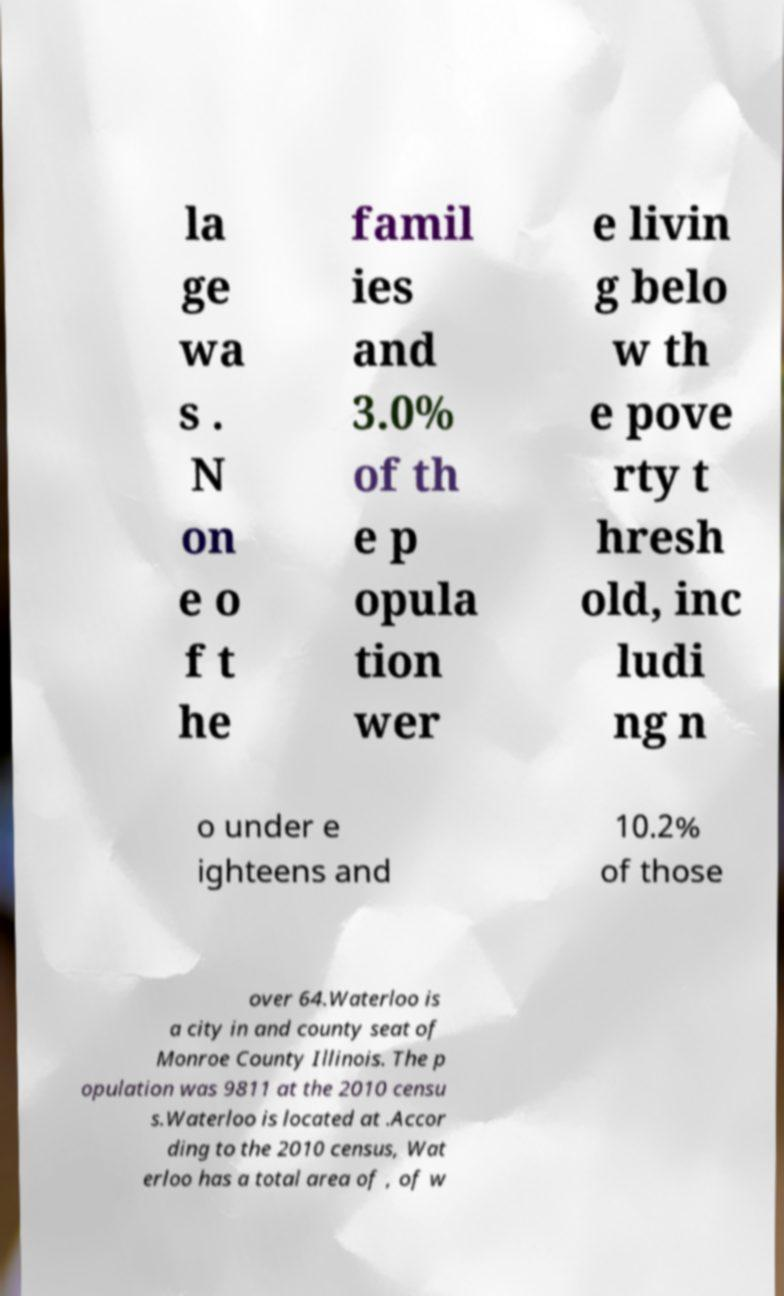Can you accurately transcribe the text from the provided image for me? la ge wa s . N on e o f t he famil ies and 3.0% of th e p opula tion wer e livin g belo w th e pove rty t hresh old, inc ludi ng n o under e ighteens and 10.2% of those over 64.Waterloo is a city in and county seat of Monroe County Illinois. The p opulation was 9811 at the 2010 censu s.Waterloo is located at .Accor ding to the 2010 census, Wat erloo has a total area of , of w 